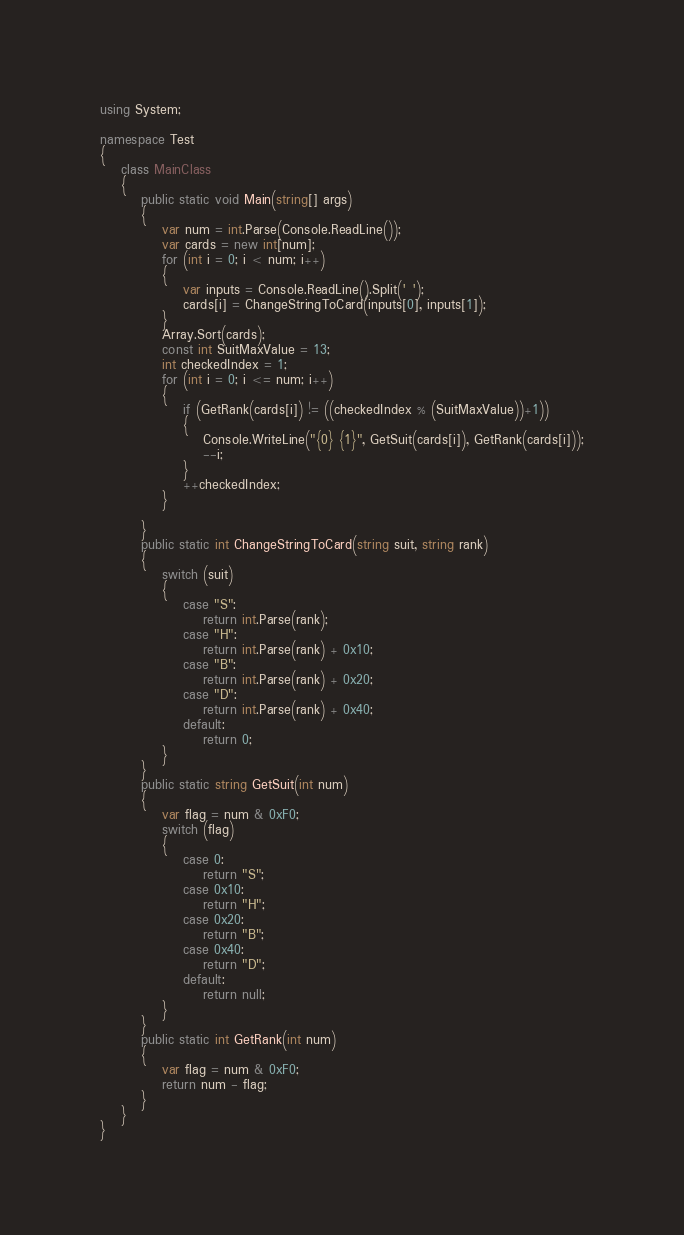<code> <loc_0><loc_0><loc_500><loc_500><_C#_>using System;

namespace Test
{
    class MainClass
    {
        public static void Main(string[] args)
        {
            var num = int.Parse(Console.ReadLine());
            var cards = new int[num];
            for (int i = 0; i < num; i++)
            {
                var inputs = Console.ReadLine().Split(' ');
                cards[i] = ChangeStringToCard(inputs[0], inputs[1]);
            }
            Array.Sort(cards);
            const int SuitMaxValue = 13;
            int checkedIndex = 1;
            for (int i = 0; i <= num; i++)
            {
                if (GetRank(cards[i]) != ((checkedIndex % (SuitMaxValue))+1))
                {
                    Console.WriteLine("{0} {1}", GetSuit(cards[i]), GetRank(cards[i]));
                    --i;
                }
                ++checkedIndex;
            }
            
        }
        public static int ChangeStringToCard(string suit, string rank)
        {
            switch (suit)
            {
                case "S":
                    return int.Parse(rank);
                case "H":
                    return int.Parse(rank) + 0x10;
                case "B":
                    return int.Parse(rank) + 0x20;
                case "D":
                    return int.Parse(rank) + 0x40;
                default:
                    return 0;
            }
        }
        public static string GetSuit(int num)
        {
            var flag = num & 0xF0;
            switch (flag)
            {
                case 0:
                    return "S";
                case 0x10:
                    return "H";
                case 0x20:
                    return "B";
                case 0x40:
                    return "D";
                default:
                    return null;
            }
        }
        public static int GetRank(int num)
        {
            var flag = num & 0xF0;
            return num - flag;
        }
    }
}</code> 